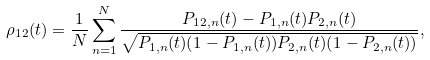Convert formula to latex. <formula><loc_0><loc_0><loc_500><loc_500>\rho _ { 1 2 } ( t ) = \frac { 1 } { N } \sum _ { n = 1 } ^ { N } \frac { P _ { 1 2 , n } ( t ) - P _ { 1 , n } ( t ) P _ { 2 , n } ( t ) } { \sqrt { P _ { 1 , n } ( t ) ( 1 - P _ { 1 , n } ( t ) ) P _ { 2 , n } ( t ) ( 1 - P _ { 2 , n } ( t ) ) } } ,</formula> 